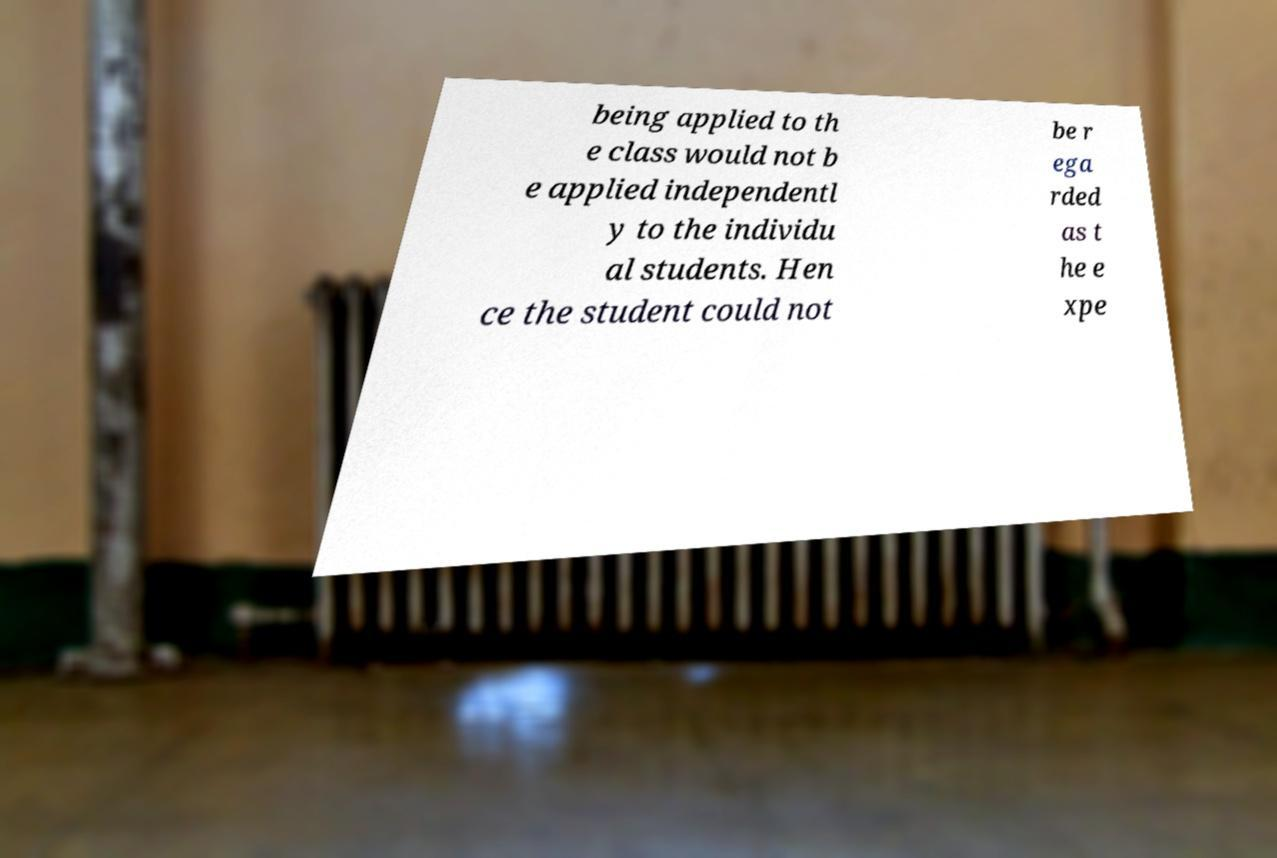Can you accurately transcribe the text from the provided image for me? being applied to th e class would not b e applied independentl y to the individu al students. Hen ce the student could not be r ega rded as t he e xpe 